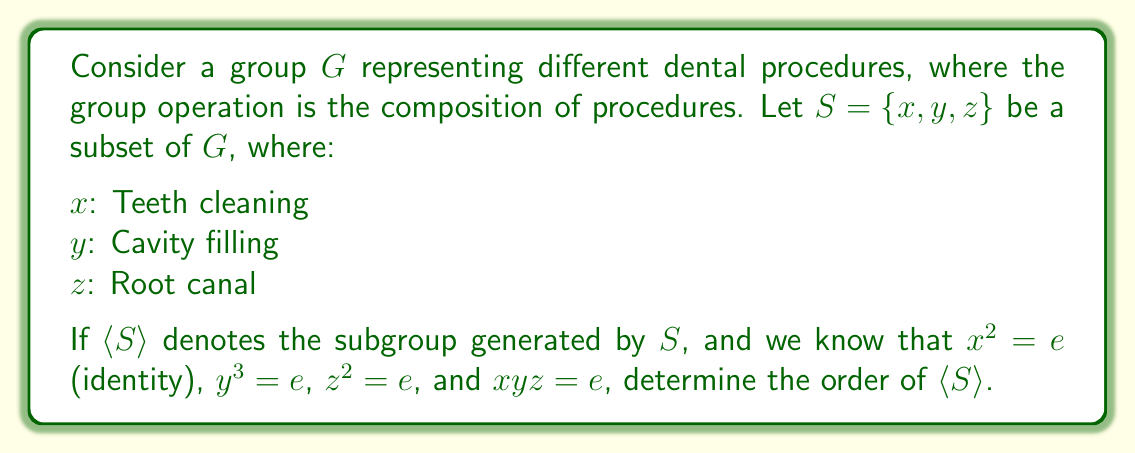Teach me how to tackle this problem. To determine the order of $\langle S \rangle$, we need to analyze the structure of the subgroup generated by $S$. Let's approach this step-by-step:

1) First, we note the given relations:
   $x^2 = e$, $y^3 = e$, $z^2 = e$, and $xyz = e$

2) From $xyz = e$, we can derive: $z = (xy)^{-1} = yx$ (since in groups, $(ab)^{-1} = b^{-1}a^{-1}$)

3) This means that $z$ can be expressed in terms of $x$ and $y$, so we only need to consider combinations of $x$ and $y$ to generate all elements of $\langle S \rangle$.

4) The possible combinations of $x$ and $y$ are:
   $e, x, y, xy, yx, y^2, xy^2, yx^2 (=yx)$

5) We can verify that these are all distinct:
   - $x \neq e$ (since $x^2 = e$ and $x \neq e$)
   - $y \neq e$ and $y^2 \neq e$ (since $y^3 = e$ and $y \neq e$)
   - $xy \neq yx$ (if they were equal, we'd have $x = y^{-1}xy = y$, which is not true)
   - $xy^2 \neq yx$ (if they were equal, we'd have $xy = y$, which is not true)

6) Therefore, the subgroup $\langle S \rangle$ contains exactly 8 elements.

This structure is isomorphic to the dihedral group $D_4$, which represents the symmetries of a square.
Answer: The order of $\langle S \rangle$ is 8. 